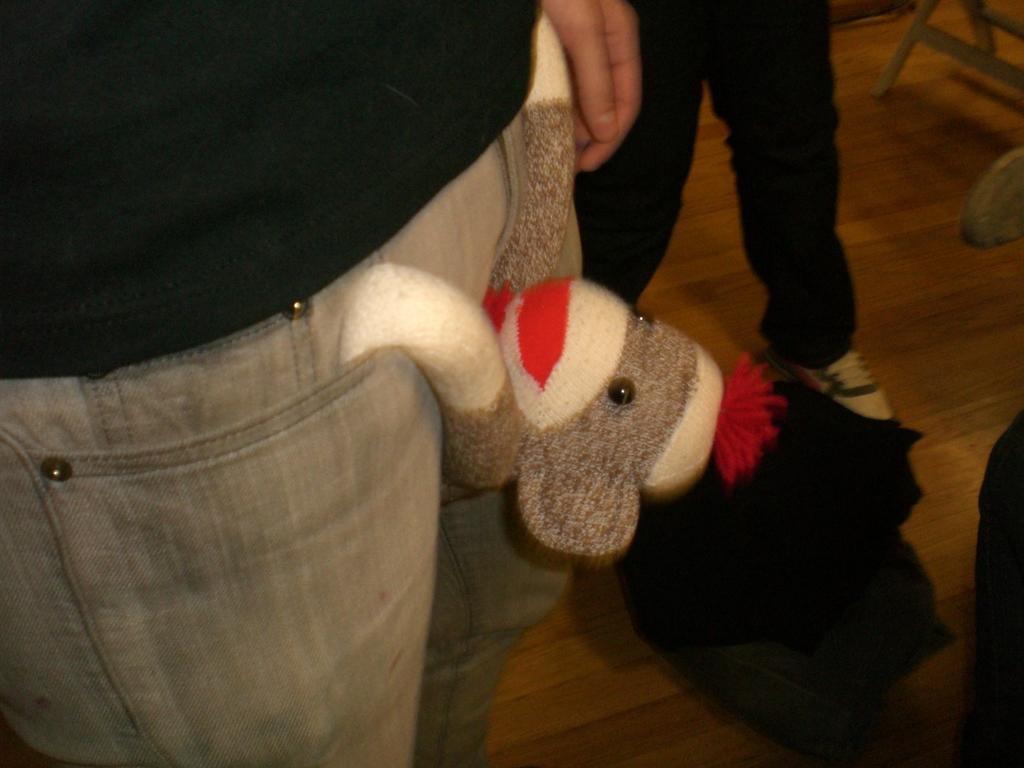Describe this image in one or two sentences. In this image there is a dog hanging from a person's pocket, beside the person there are legs of another person, beside him there is a chair. 